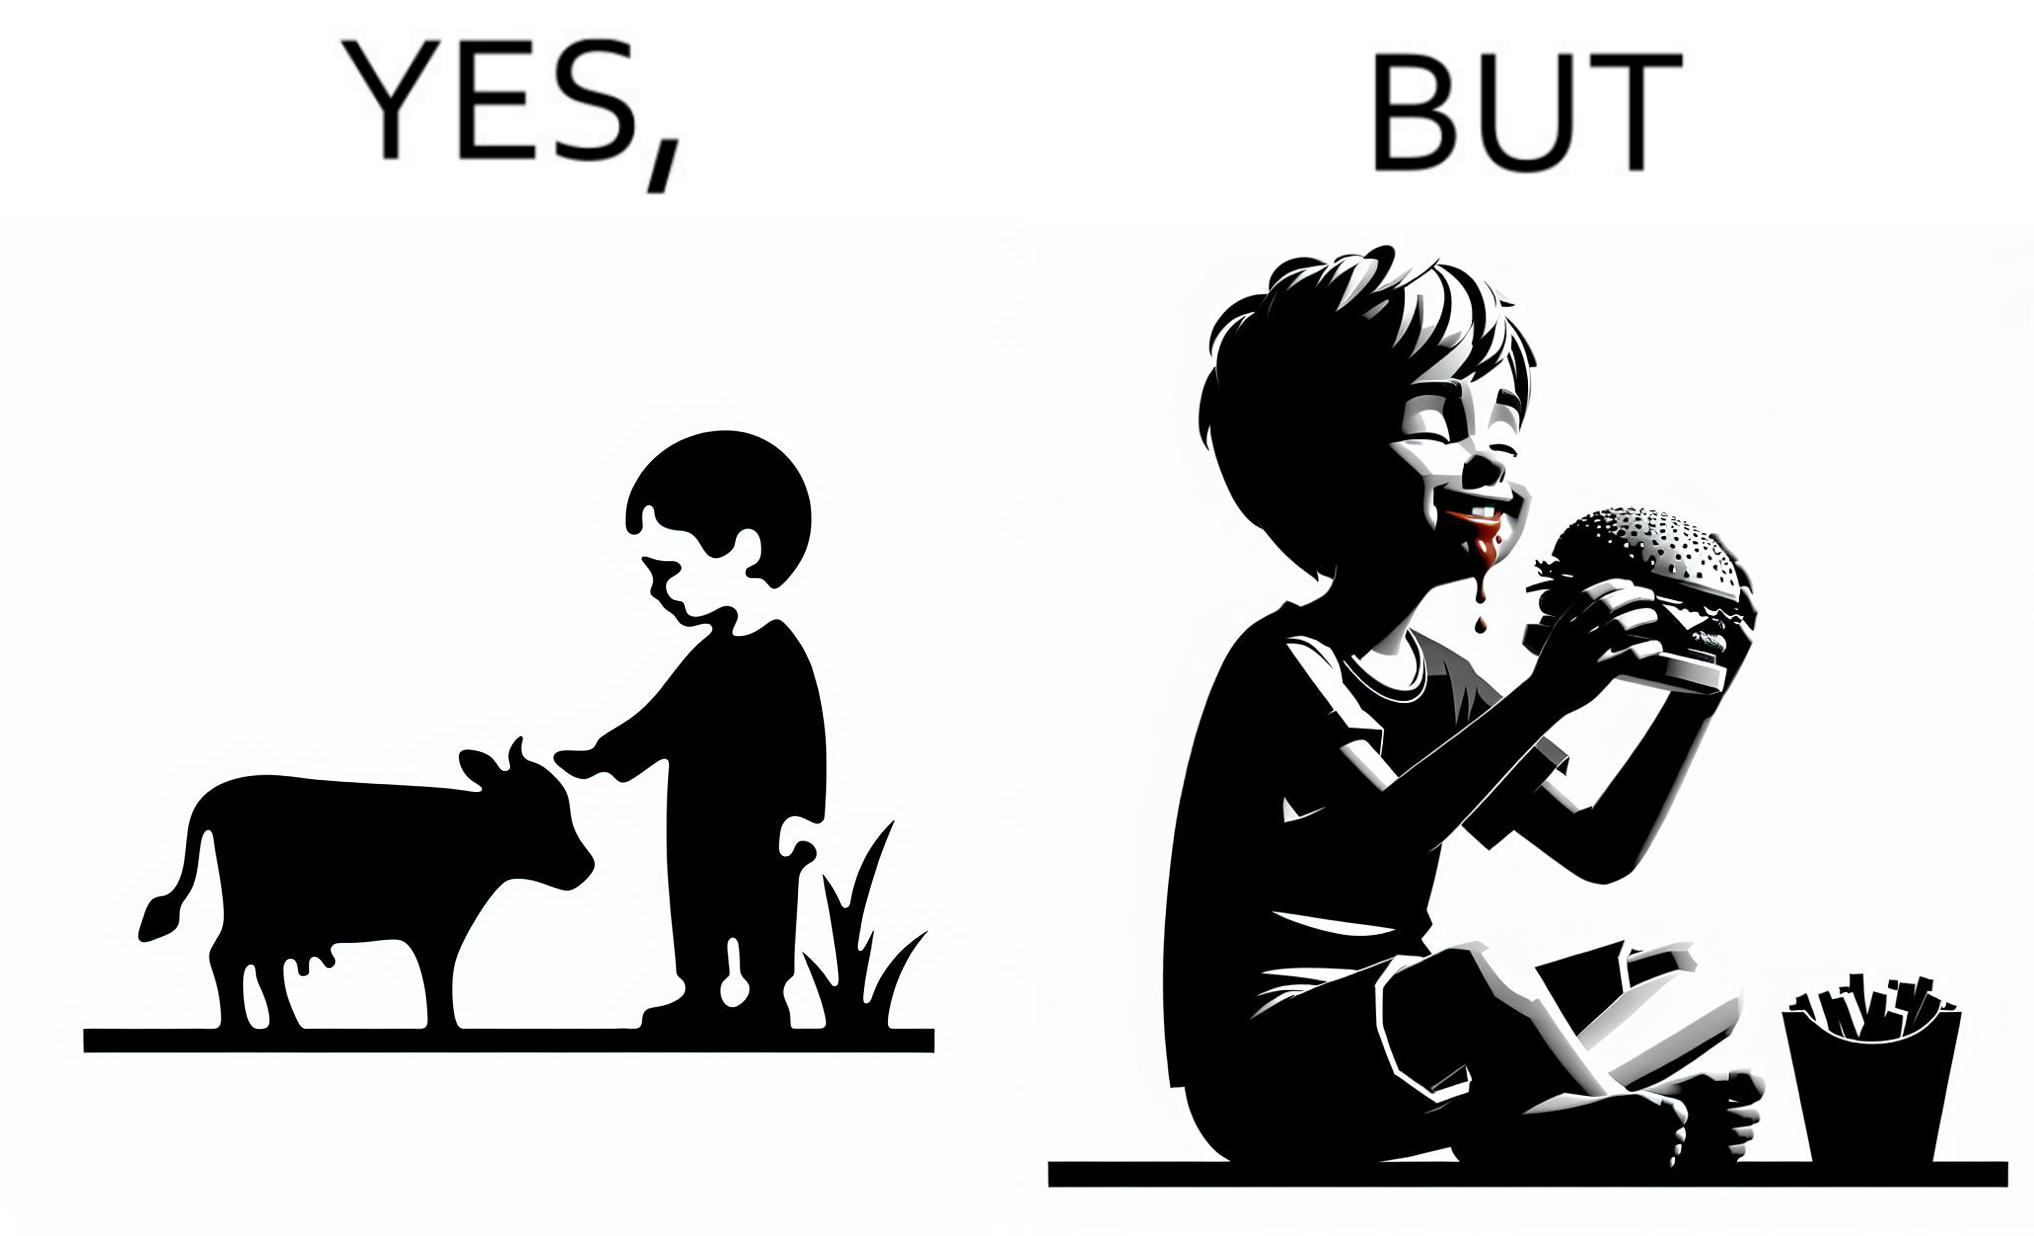Describe the content of this image. The irony is that the boy is petting the cow to show that he cares about the animal, but then he also eats hamburgers made from the same cows 